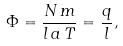Convert formula to latex. <formula><loc_0><loc_0><loc_500><loc_500>\Phi = \frac { N \, m } { l \, a \, T } = \frac { q } { l } ,</formula> 